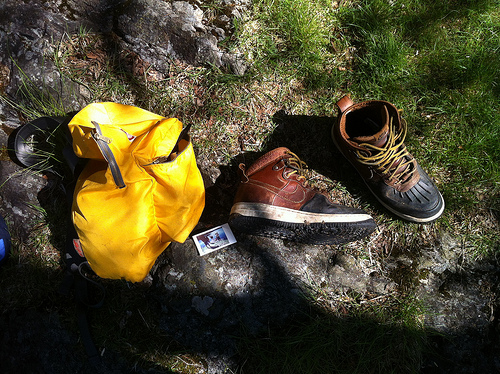<image>
Is there a picture in front of the shoe? No. The picture is not in front of the shoe. The spatial positioning shows a different relationship between these objects. 